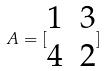Convert formula to latex. <formula><loc_0><loc_0><loc_500><loc_500>A = [ \begin{matrix} 1 & 3 \\ 4 & 2 \end{matrix} ]</formula> 